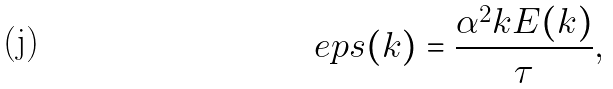Convert formula to latex. <formula><loc_0><loc_0><loc_500><loc_500>\ e p s ( k ) = \frac { \alpha ^ { 2 } k E ( k ) } { \tau } ,</formula> 